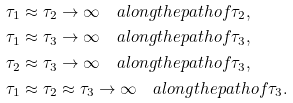Convert formula to latex. <formula><loc_0><loc_0><loc_500><loc_500>& \tau _ { 1 } \approx \tau _ { 2 } \to \infty \quad a l o n g t h e p a t h o f \tau _ { 2 } , \\ & \tau _ { 1 } \approx \tau _ { 3 } \to \infty \quad a l o n g t h e p a t h o f \tau _ { 3 } , \\ & \tau _ { 2 } \approx \tau _ { 3 } \to \infty \quad a l o n g t h e p a t h o f \tau _ { 3 } , \\ & \tau _ { 1 } \approx \tau _ { 2 } \approx \tau _ { 3 } \to \infty \quad a l o n g t h e p a t h o f \tau _ { 3 } .</formula> 